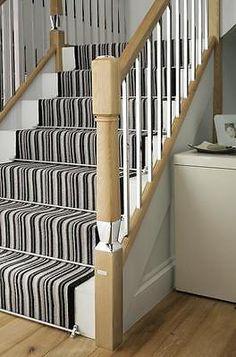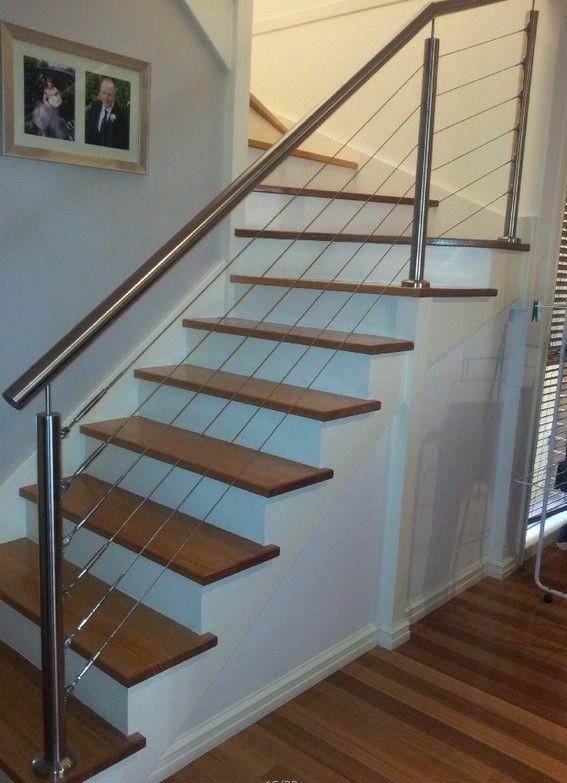The first image is the image on the left, the second image is the image on the right. For the images displayed, is the sentence "At least one image was taken from upstairs." factually correct? Answer yes or no. No. 